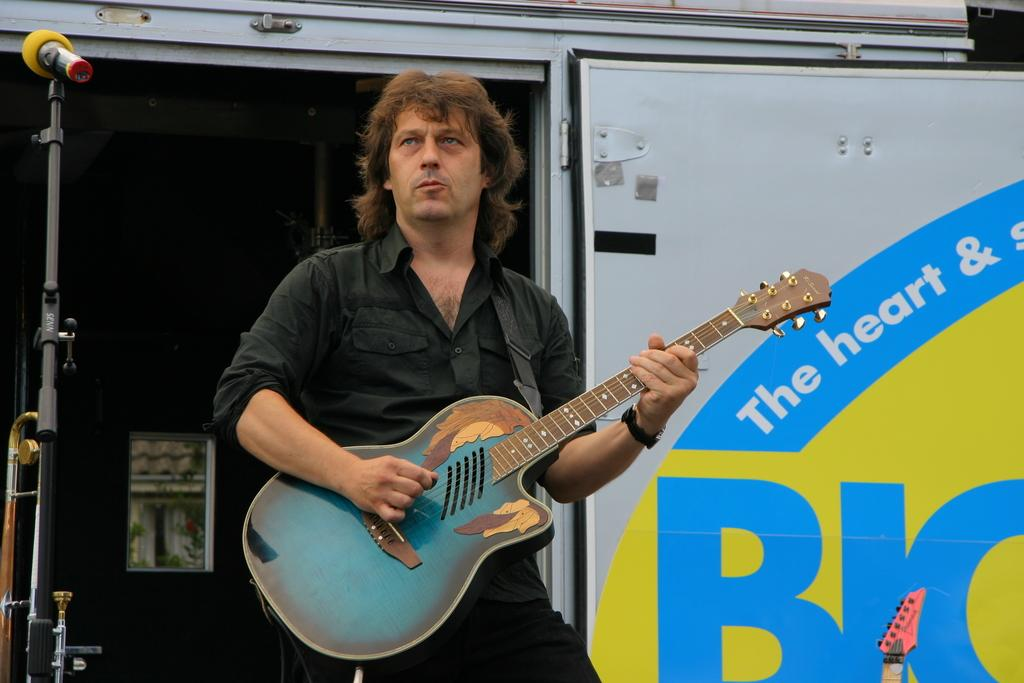What vehicle is present in the image? There is a van in the image. What is the person outside the van doing? The person is holding a guitar. What object is beside the person? There is a microphone beside the person. What can be seen in the background of the image? There is a window visible in the background. Can you tell me how many yaks are visible in the image? There are no yaks present in the image. What type of activity is the kitty participating in with the person in the image? There is no kitty present in the image, so it cannot be participating in any activity with the person. 